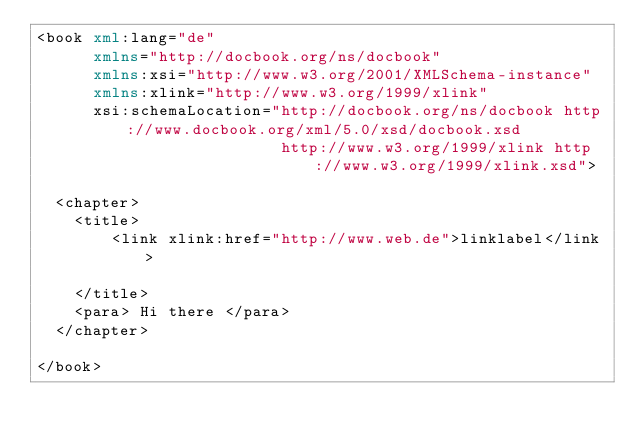Convert code to text. <code><loc_0><loc_0><loc_500><loc_500><_XML_><book xml:lang="de"
      xmlns="http://docbook.org/ns/docbook"
      xmlns:xsi="http://www.w3.org/2001/XMLSchema-instance"
      xmlns:xlink="http://www.w3.org/1999/xlink"
      xsi:schemaLocation="http://docbook.org/ns/docbook http://www.docbook.org/xml/5.0/xsd/docbook.xsd
                          http://www.w3.org/1999/xlink http://www.w3.org/1999/xlink.xsd">

  <chapter>
    <title>
        <link xlink:href="http://www.web.de">linklabel</link>

    </title>
    <para> Hi there </para>
  </chapter>

</book></code> 